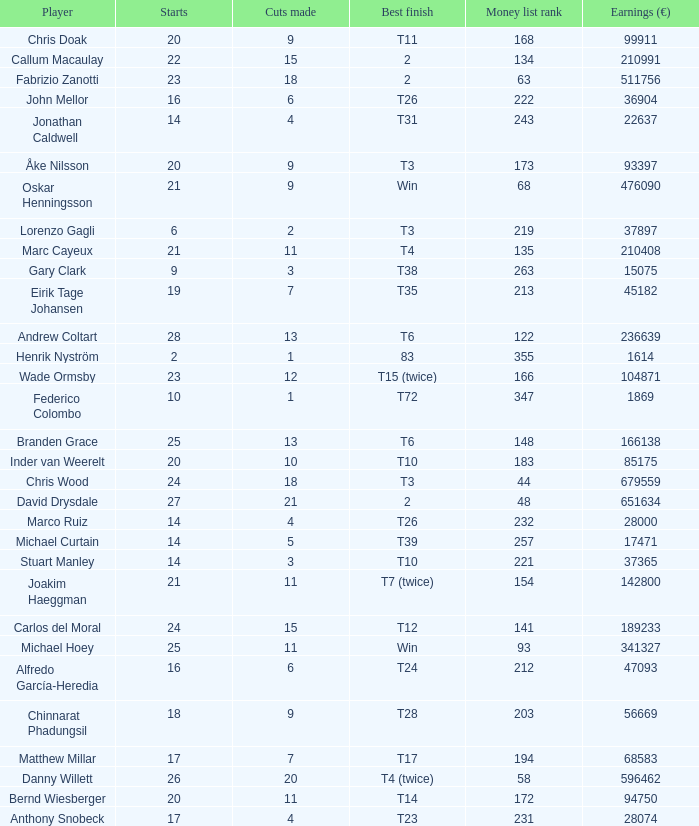How many cuts did Gary Clark make? 3.0. 